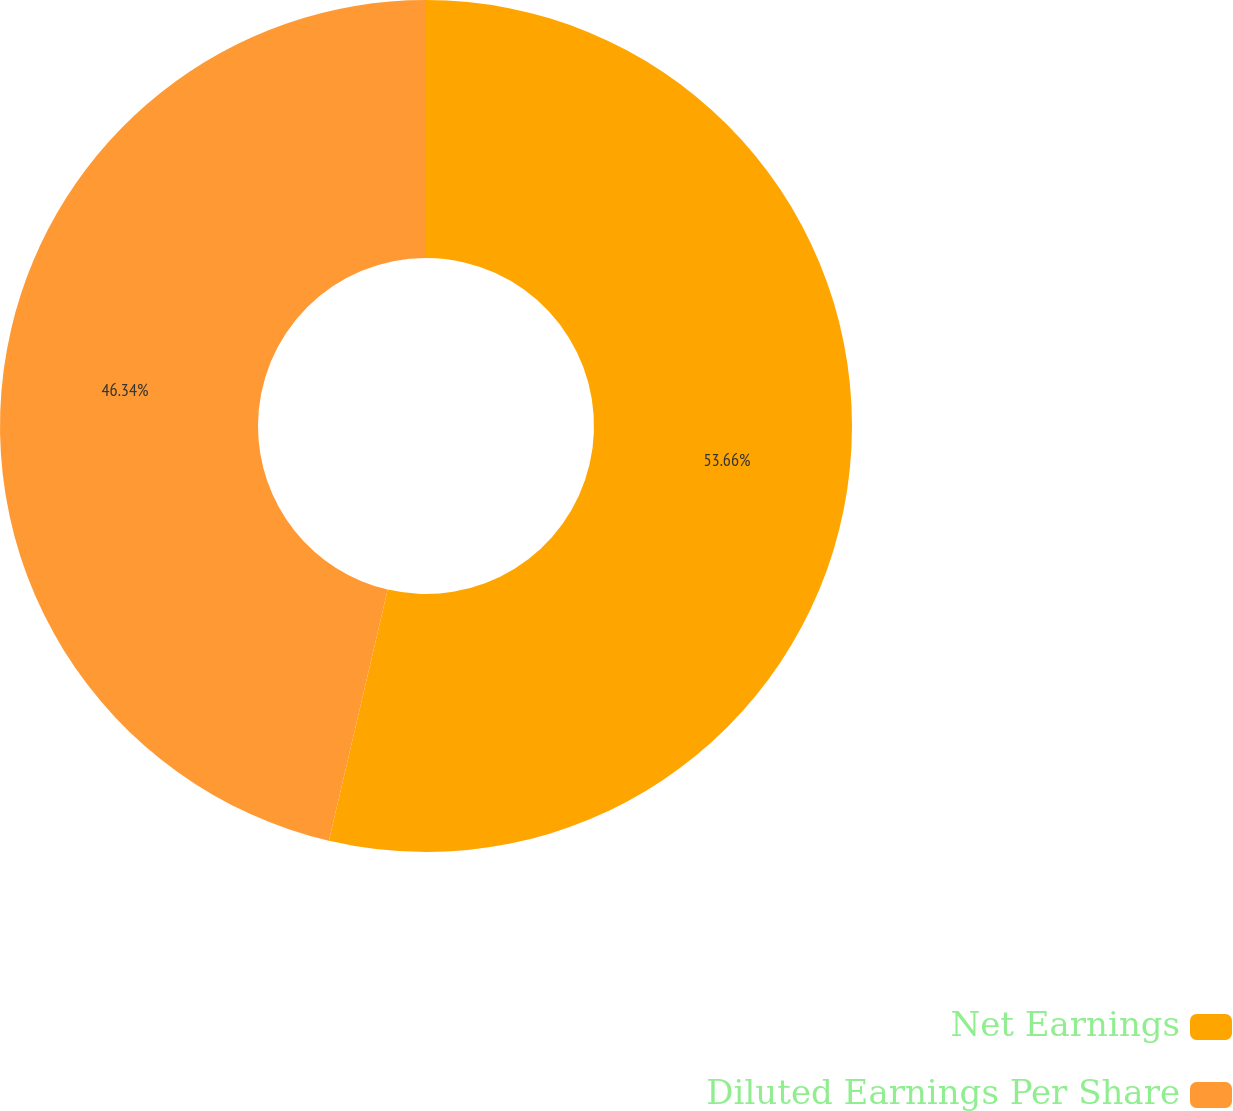<chart> <loc_0><loc_0><loc_500><loc_500><pie_chart><fcel>Net Earnings<fcel>Diluted Earnings Per Share<nl><fcel>53.66%<fcel>46.34%<nl></chart> 